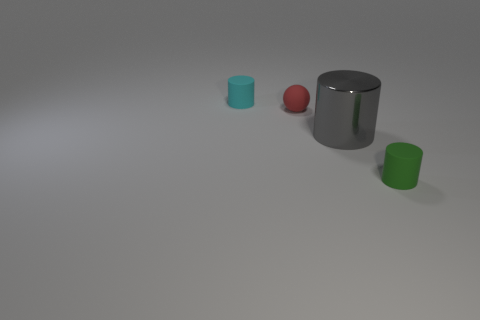Add 2 big blue metal objects. How many objects exist? 6 Subtract all balls. How many objects are left? 3 Add 4 tiny cylinders. How many tiny cylinders are left? 6 Add 3 matte things. How many matte things exist? 6 Subtract 0 green balls. How many objects are left? 4 Subtract all large gray metallic objects. Subtract all rubber objects. How many objects are left? 0 